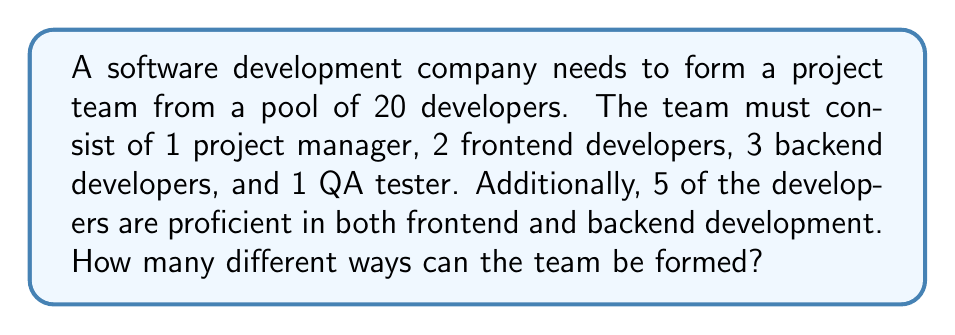Help me with this question. Let's break this down step-by-step:

1) First, let's choose the project manager:
   There are 20 developers to choose from.
   $$(20)_1 = 20$$ ways to select the project manager

2) Next, let's choose the frontend developers:
   We have 19 developers left, 5 of whom are proficient in both frontend and backend.
   So we have 19 developers to choose from for the first frontend position, and then 18 for the second.
   $$(19 \cdot 18) = 342$$ ways to select the frontend developers

3) Now, for the backend developers:
   We have 17 developers left, including the 5 who are proficient in both.
   We need to choose 3 from these 17.
   $$\binom{17}{3} = \frac{17!}{3!(17-3)!} = 680$$ ways to select the backend developers

4) Finally, for the QA tester:
   We have 14 developers left to choose from.
   $$(14)_1 = 14$$ ways to select the QA tester

5) By the multiplication principle, the total number of ways to form the team is:
   $$20 \cdot 342 \cdot 680 \cdot 14 = 65,121,600$$

Therefore, there are 65,121,600 different ways to form the team.
Answer: 65,121,600 